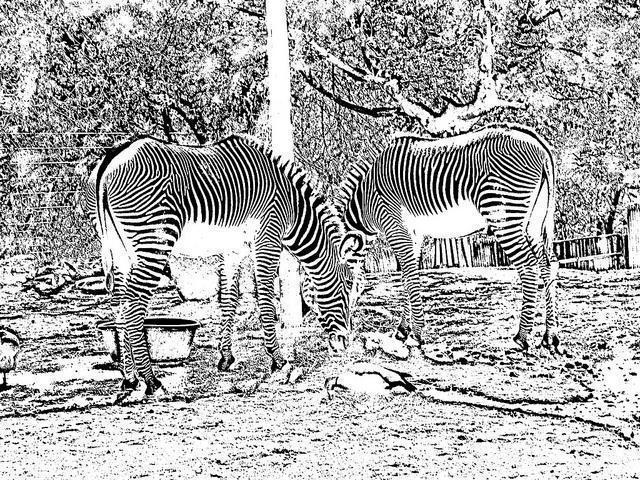How was the photo turned black and white?
From the following four choices, select the correct answer to address the question.
Options: Weather, filter, crayons, time. Filter. 